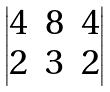<formula> <loc_0><loc_0><loc_500><loc_500>\begin{vmatrix} 4 & 8 & 4 \\ 2 & 3 & 2 \end{vmatrix}</formula> 